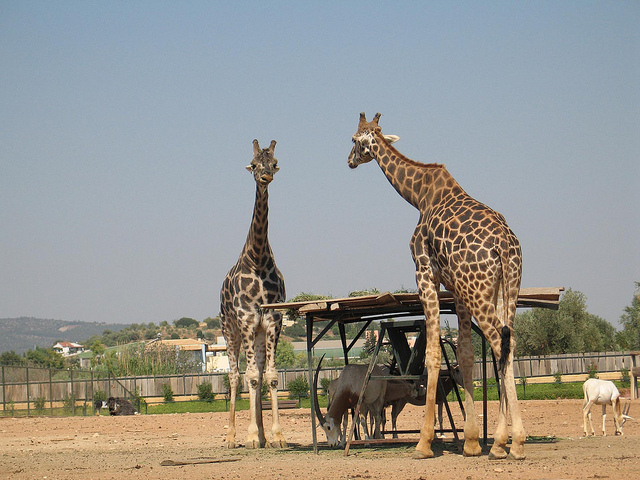<image>What other animals are in the photo? I don't know what other animals are in the photo. They could be goats, giraffes, ibex, impala, or some kind of African herd animal. What other animals are in the photo? I don't know what other animals are in the photo. It can be seen goats, saiga antelope, giraffes, ibex, or some kind of african herd animal. 